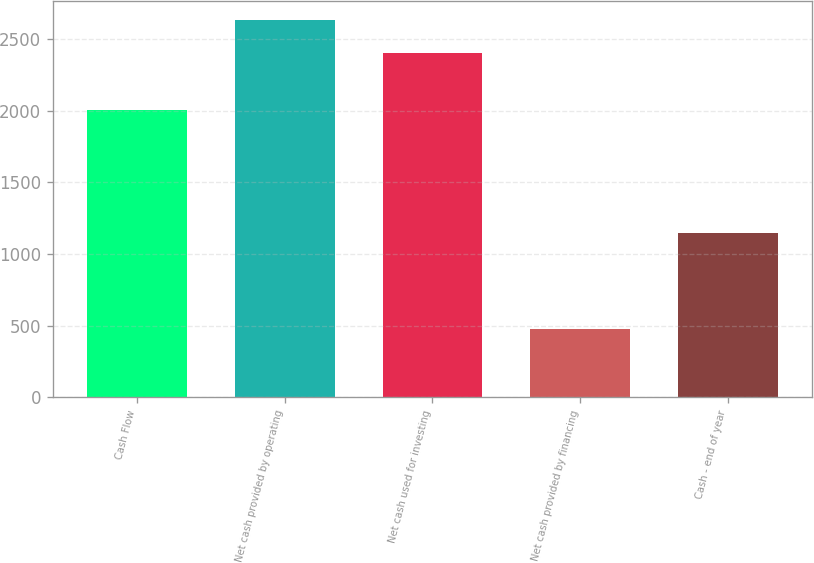Convert chart to OTSL. <chart><loc_0><loc_0><loc_500><loc_500><bar_chart><fcel>Cash Flow<fcel>Net cash provided by operating<fcel>Net cash used for investing<fcel>Net cash provided by financing<fcel>Cash - end of year<nl><fcel>2004<fcel>2634<fcel>2401<fcel>477<fcel>1148<nl></chart> 